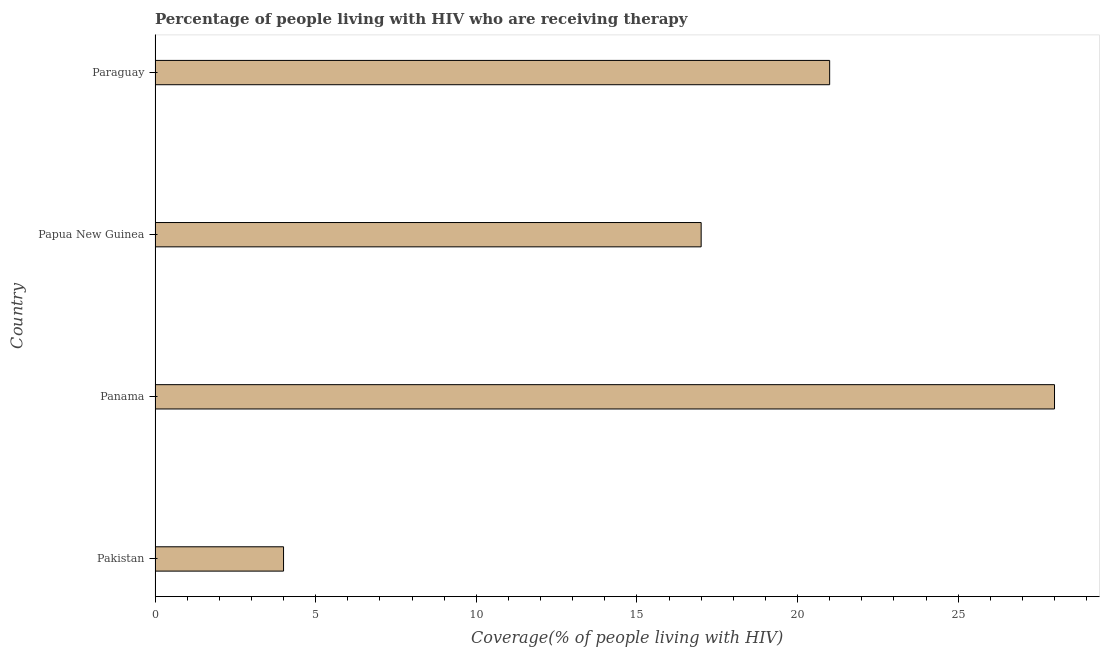What is the title of the graph?
Offer a terse response. Percentage of people living with HIV who are receiving therapy. What is the label or title of the X-axis?
Provide a short and direct response. Coverage(% of people living with HIV). What is the label or title of the Y-axis?
Give a very brief answer. Country. What is the antiretroviral therapy coverage in Pakistan?
Offer a very short reply. 4. In which country was the antiretroviral therapy coverage maximum?
Keep it short and to the point. Panama. In which country was the antiretroviral therapy coverage minimum?
Provide a succinct answer. Pakistan. What is the sum of the antiretroviral therapy coverage?
Provide a succinct answer. 70. What is the difference between the antiretroviral therapy coverage in Pakistan and Papua New Guinea?
Provide a succinct answer. -13. What is the ratio of the antiretroviral therapy coverage in Pakistan to that in Papua New Guinea?
Your answer should be compact. 0.23. Is the sum of the antiretroviral therapy coverage in Pakistan and Papua New Guinea greater than the maximum antiretroviral therapy coverage across all countries?
Provide a short and direct response. No. What is the difference between the highest and the lowest antiretroviral therapy coverage?
Keep it short and to the point. 24. In how many countries, is the antiretroviral therapy coverage greater than the average antiretroviral therapy coverage taken over all countries?
Keep it short and to the point. 2. Are all the bars in the graph horizontal?
Make the answer very short. Yes. How many countries are there in the graph?
Offer a terse response. 4. What is the difference between two consecutive major ticks on the X-axis?
Your response must be concise. 5. What is the Coverage(% of people living with HIV) of Pakistan?
Provide a short and direct response. 4. What is the Coverage(% of people living with HIV) in Panama?
Your answer should be compact. 28. What is the difference between the Coverage(% of people living with HIV) in Pakistan and Papua New Guinea?
Keep it short and to the point. -13. What is the difference between the Coverage(% of people living with HIV) in Pakistan and Paraguay?
Ensure brevity in your answer.  -17. What is the difference between the Coverage(% of people living with HIV) in Panama and Paraguay?
Ensure brevity in your answer.  7. What is the ratio of the Coverage(% of people living with HIV) in Pakistan to that in Panama?
Provide a succinct answer. 0.14. What is the ratio of the Coverage(% of people living with HIV) in Pakistan to that in Papua New Guinea?
Offer a terse response. 0.23. What is the ratio of the Coverage(% of people living with HIV) in Pakistan to that in Paraguay?
Offer a very short reply. 0.19. What is the ratio of the Coverage(% of people living with HIV) in Panama to that in Papua New Guinea?
Offer a very short reply. 1.65. What is the ratio of the Coverage(% of people living with HIV) in Panama to that in Paraguay?
Offer a terse response. 1.33. What is the ratio of the Coverage(% of people living with HIV) in Papua New Guinea to that in Paraguay?
Offer a very short reply. 0.81. 